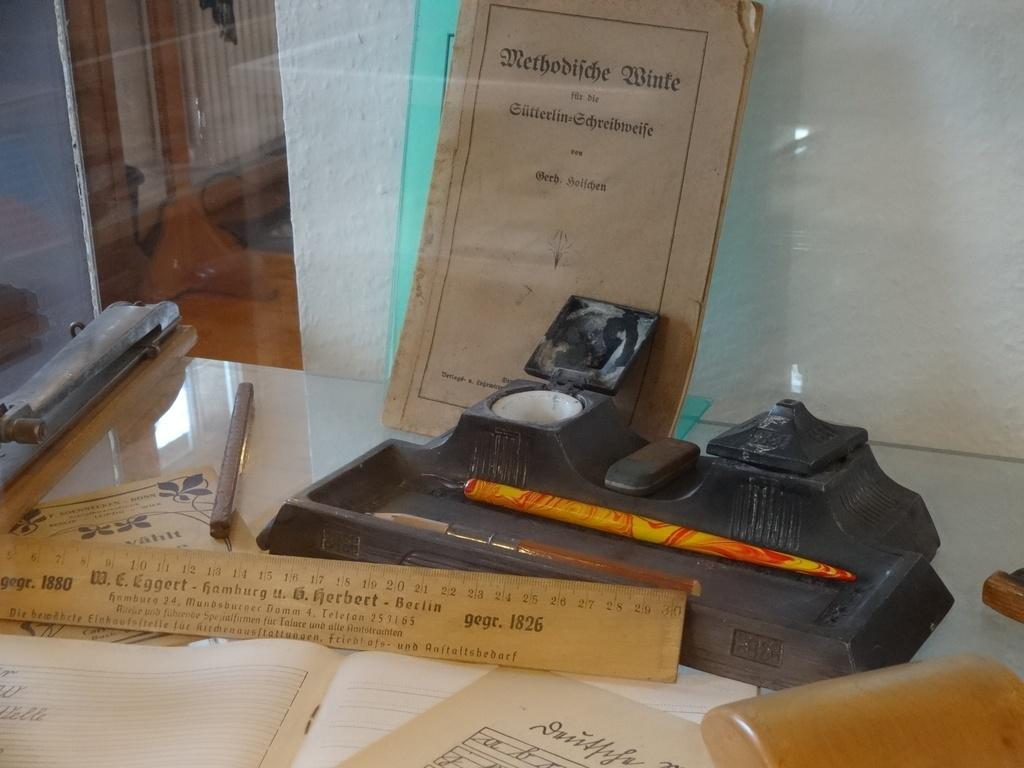<image>
Render a clear and concise summary of the photo. A wooden ruler in a display case has the dates 1880 and 1826 on it. 